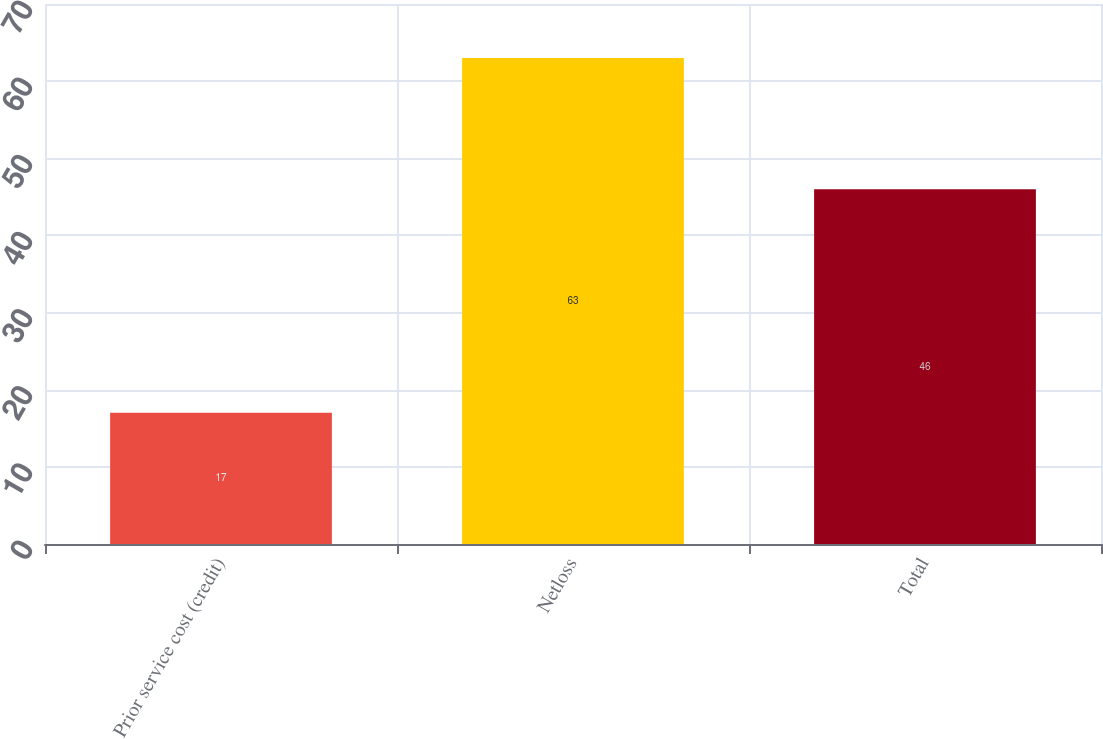<chart> <loc_0><loc_0><loc_500><loc_500><bar_chart><fcel>Prior service cost (credit)<fcel>Netloss<fcel>Total<nl><fcel>17<fcel>63<fcel>46<nl></chart> 